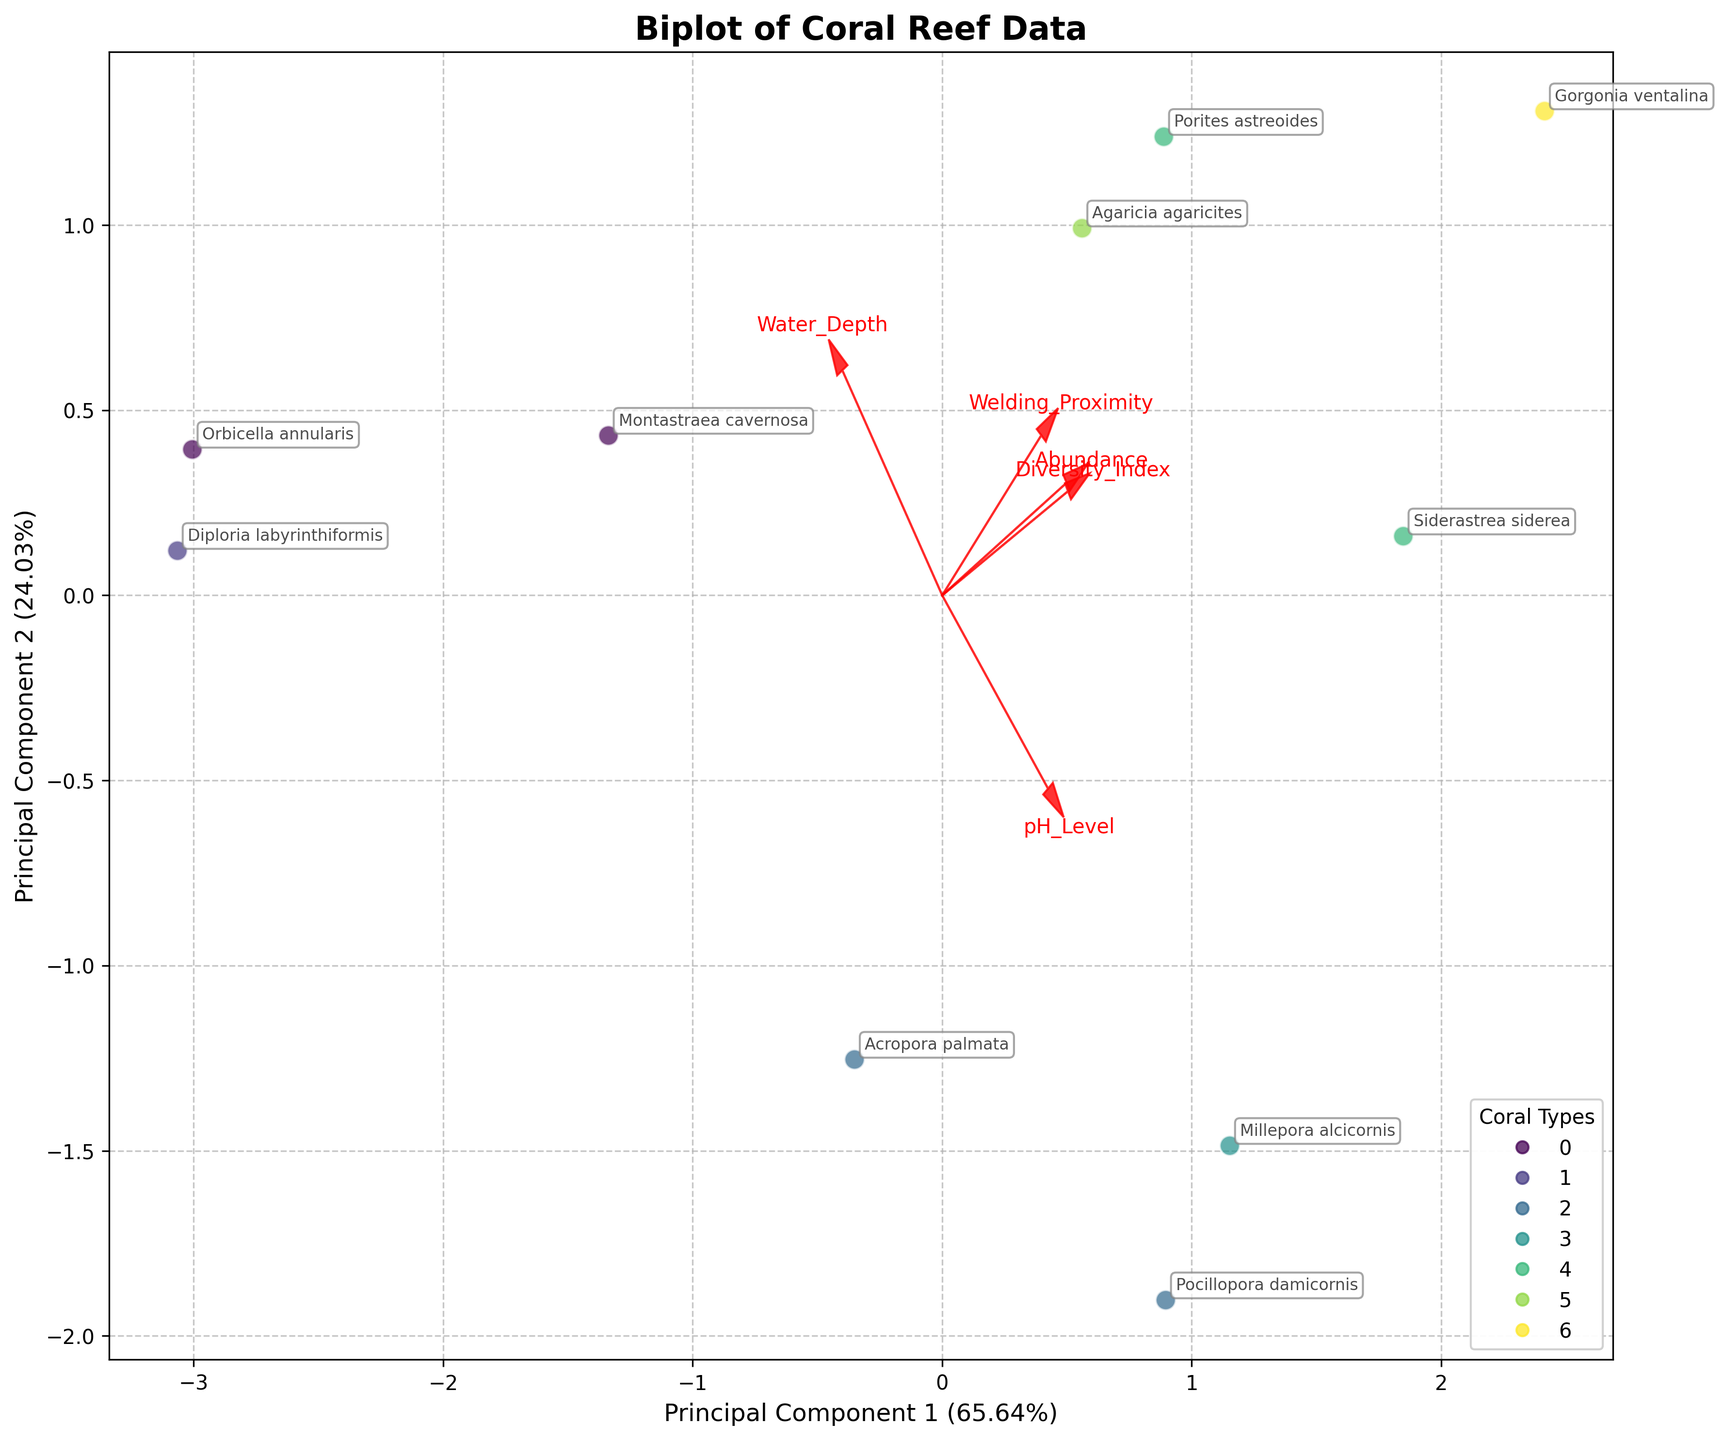What's the title of the plot? The title is prominently displayed at the top of the plot, providing a clear indication of what the figure represents.
Answer: Biplot of Coral Reef Data How many different coral types are represented in the plot? The legend on the plot shows the different colors representing the coral types, each corresponding to a unique coral type.
Answer: Six Which feature vector has the largest magnitude in the plot? The length of the arrows corresponds to the magnitude of the feature vectors, with the longest arrow representing the largest magnitude.
Answer: Welding_Proximity Which coral type appears to have the highest diversity index? The annotation of species names near the data points can help identify which coral type shows the highest diversity index based on point positions.
Answer: Soft What are the labels on the x-axis and y-axis of the biplot? The labels appear next to the respective axes, indicating what each principal component represents.
Answer: Principal Component 1 and Principal Component 2 Which species is located furthest from the origin? By observing the plot, the species that are located at the edges of the cluster are furthest from the origin.
Answer: Gorgonia ventalina What principal component explains more variance in the data? The labels of the axes provide the explained variance ratio for each principal component.
Answer: Principal Component 1 How are the branching corals distributed in the biplot compared to the massive corals? By observing the scatter points and their annotations, we can see the distribution of branching and massive corals and compare their positions.
Answer: Branching corals are scattered around while massive corals cluster more closely together Which feature is most contributing to Principal Component 1? The projection of the feature vectors on Principal Component 1 shows their contributions. The longest projection indicates the most contributing feature.
Answer: Abundance Which coral type has the shortest distance to the welding site? The data points labeling the species, along with the feature vector of Welding_Proximity, indicate the proximity of coral types to the welding site.
Answer: Boulder 